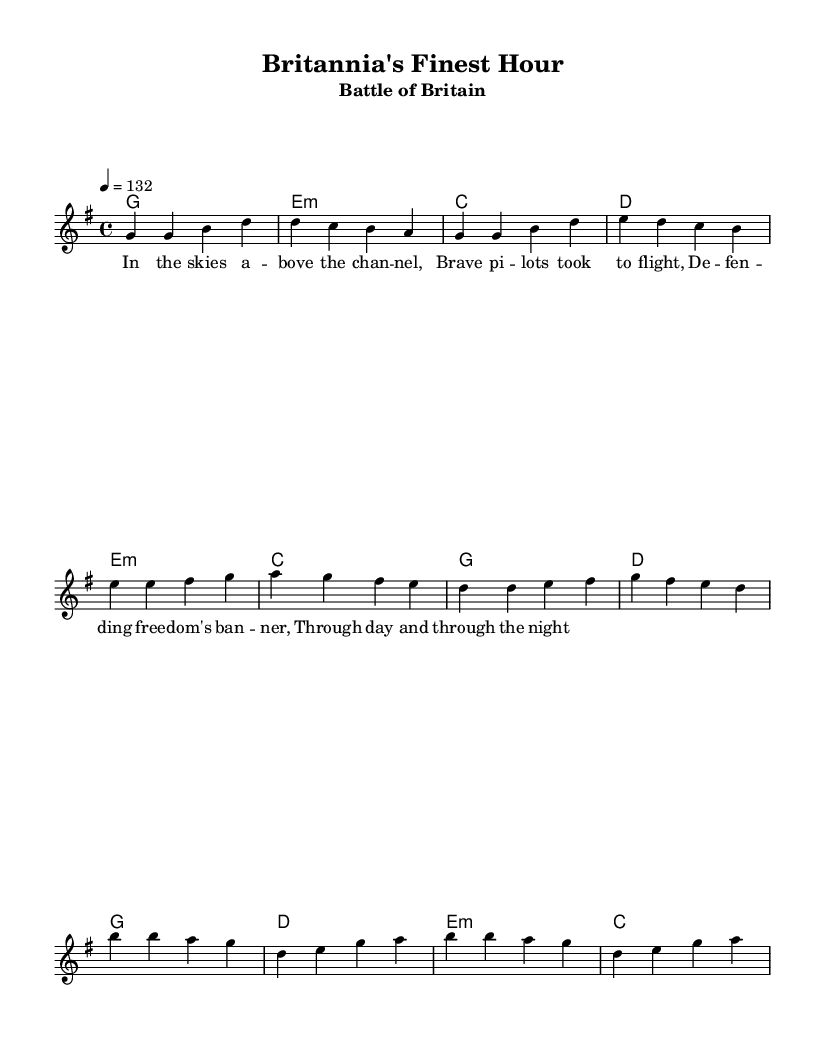What is the key signature of this music? The key signature is G major, which has one sharp (F#). This can be determined by looking at the key indication at the beginning of the score, which shows a G with a single sharp.
Answer: G major What is the time signature of this music? The time signature is 4/4, which can be found next to the key signature at the beginning of the piece. This indicates that there are four beats in each measure and a quarter note receives one beat.
Answer: 4/4 What is the tempo marking for this piece? The tempo marking is "4 = 132", which indicates that there are 132 quarter note beats per minute. This information is specified in the tempo section of the score.
Answer: 132 What is the structure of this piece? The structure consists of a verse, pre-chorus, and chorus. This can be analyzed by looking at the sections indicated by the lyrics and their respective melodies in the sheet music.
Answer: Verse, Pre-Chorus, Chorus How many measures are in the verse? The verse has four measures, as evident from counting the groups of four beats within the section where the lyrics are set. Each line of lyrics corresponds to one measure of music.
Answer: 4 Which section features a change in harmonic progression? The pre-chorus features a change in harmonic progression, as it shifts to different chords compared to the verse. This can be determined by comparing the chord changes noted for each section in the score.
Answer: Pre-Chorus What mood could be conveyed by this upbeat anthem? The mood conveyed could be described as patriotic or triumphant, given that the lyrics reference defending freedom and the context of the Battle of Britain, which evokes a sense of valor and pride. This can be inferred from the energetic tempo and uplifting melody.
Answer: Patriotic 